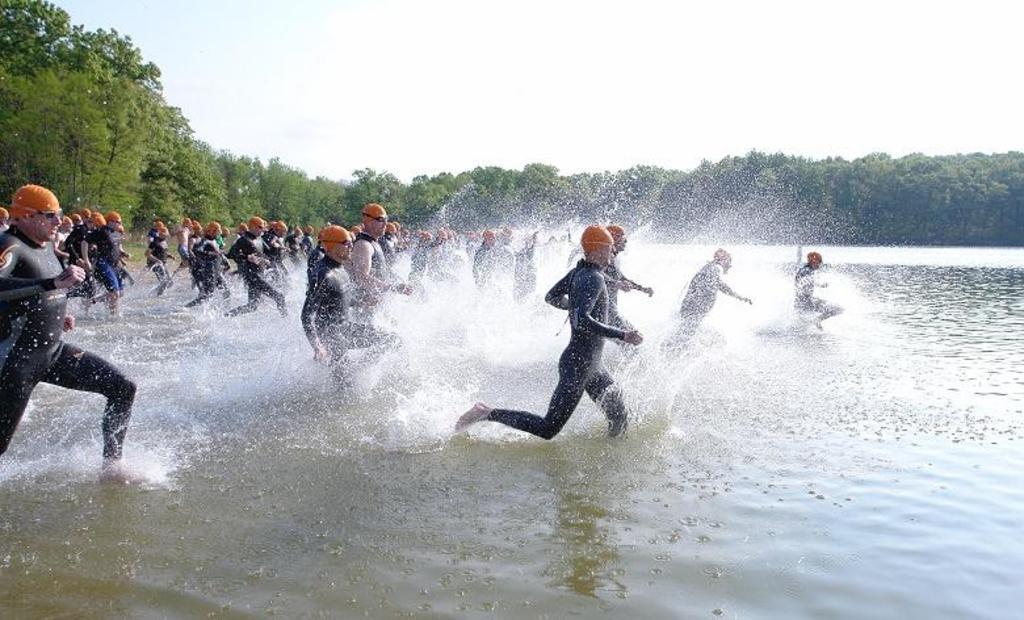Can you describe this image briefly? This image consists of many people running in the water. At the bottom, there is water. In the background, there are many trees. At the top, there is a sky. 